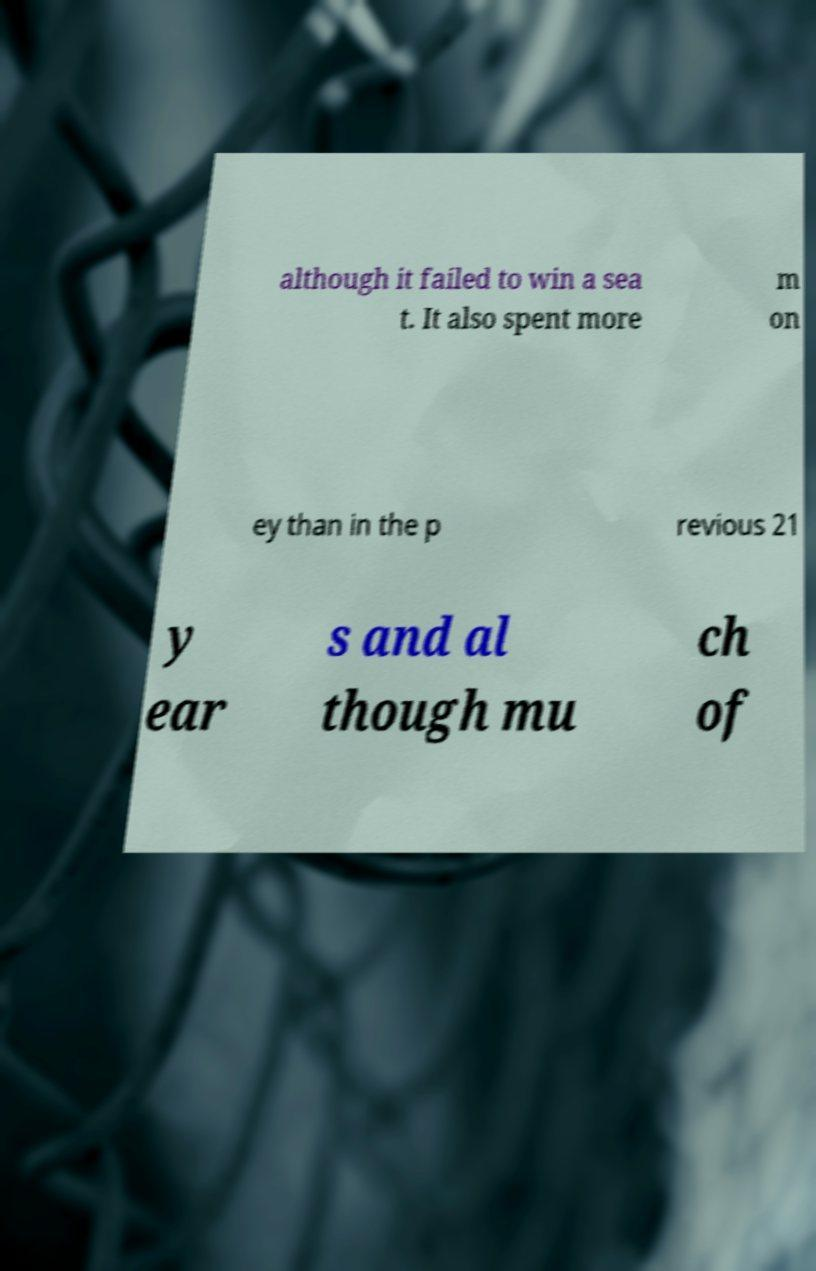For documentation purposes, I need the text within this image transcribed. Could you provide that? although it failed to win a sea t. It also spent more m on ey than in the p revious 21 y ear s and al though mu ch of 